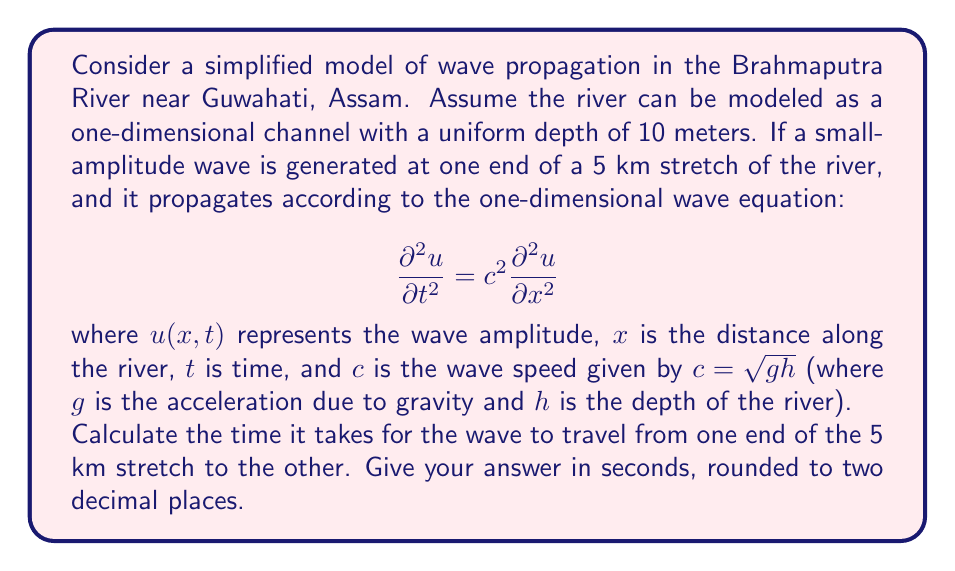What is the answer to this math problem? To solve this problem, we need to follow these steps:

1) First, we need to calculate the wave speed $c$. We're given that $c = \sqrt{gh}$, where:
   - $g$ is the acceleration due to gravity (approximately 9.81 m/s²)
   - $h$ is the depth of the river (given as 10 meters)

   Let's calculate $c$:
   
   $$c = \sqrt{gh} = \sqrt{9.81 \cdot 10} = \sqrt{98.1} \approx 9.905 \text{ m/s}$$

2) Now that we have the wave speed, we can calculate the time it takes for the wave to travel the length of the river stretch. We can use the simple distance-speed-time relationship:

   $$\text{Time} = \frac{\text{Distance}}{\text{Speed}}$$

3) We're given that the length of the river stretch is 5 km, which is 5000 meters. Let's plug this into our equation:

   $$\text{Time} = \frac{5000 \text{ m}}{9.905 \text{ m/s}} \approx 504.796 \text{ seconds}$$

4) Rounding to two decimal places, we get 504.80 seconds.

This solution assumes that the wave propagates at a constant speed throughout the river stretch, which is a simplification of the actual complex hydrodynamics of the Brahmaputra River.
Answer: 504.80 seconds 